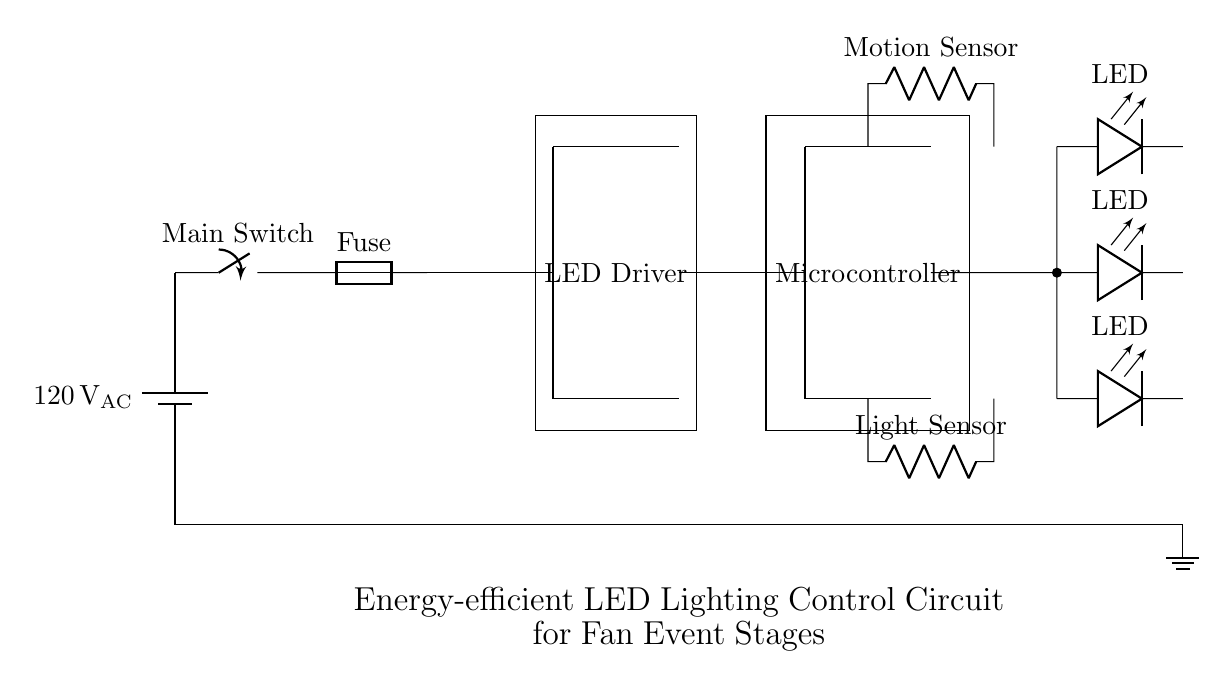What is the power source voltage in this circuit? The power source is depicted as a battery symbol labeled with 120V AC. This indicates that the voltage of the power source is 120 volts.
Answer: 120 volts What type of switch is used in this circuit? The circuit diagram includes a switch symbol labeled as "Main Switch." This indicates that the type of switch used for controlling the flow of current is a simple on-off switch.
Answer: Main Switch How many LEDs are connected in this circuit? The circuit shows three LED symbols connected in parallel; one LED is at the top, one at the middle, and one at the bottom. This confirms that there are three individual LEDs.
Answer: Three What is the purpose of the Motion Sensor in this circuit? The Motion Sensor, represented by a resistor symbol, is typically utilized to detect movement and automate the LED lighting. Its placement suggests it plays a role in controlling when the LEDs should be activated based on detected motion.
Answer: Activating LEDs based on movement Which component is responsible for driving the LED array? The LED array is connected directly to the LED Driver component, which is a rectangular box labeled accordingly. This component converts electrical power to appropriately drive the LED lights.
Answer: LED Driver What role does the Microcontroller play in this circuit? The Microcontroller, which is also represented as a rectangular box, is fundamental for processing the signals from the Motion Sensor and Light Sensor. It automates the management of the LED lighting based on these inputs, making it a critical component.
Answer: Automated control of LEDs What components are located below the Microcontroller? Below the Microcontroller, there are two components: the Motion Sensor and the Light Sensor, which are positioned one above the other. The Light Sensor detects ambient lighting levels, while the Motion Sensor detects movement, both feeding into the Microcontroller for control logic.
Answer: Motion Sensor and Light Sensor 